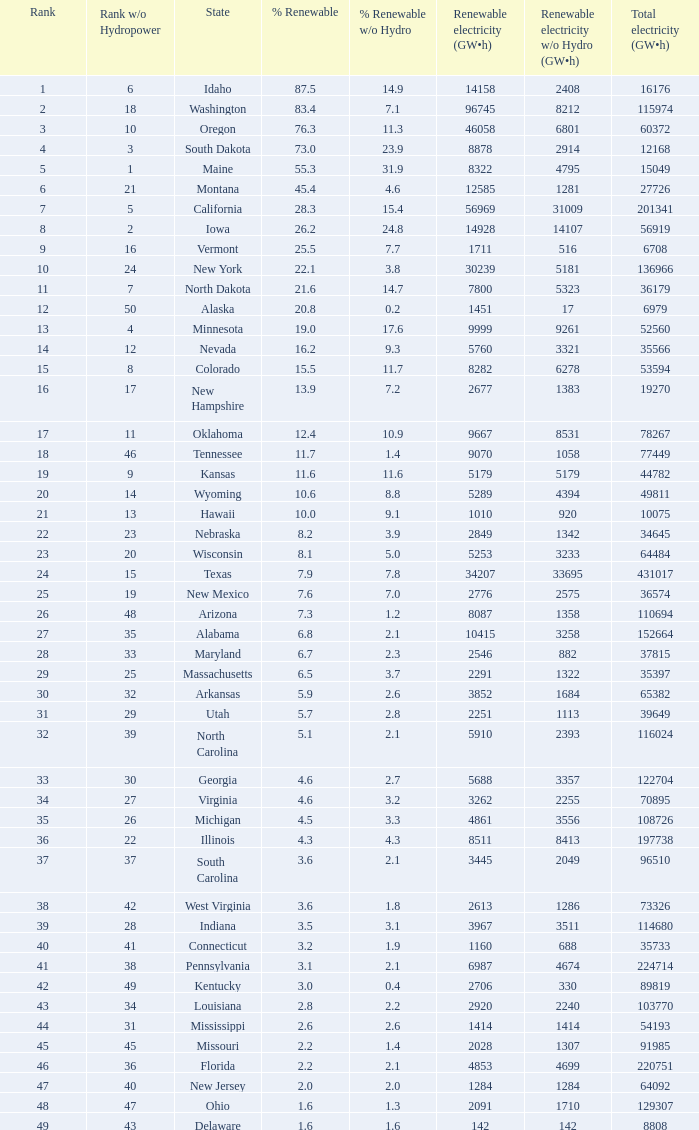Could you help me parse every detail presented in this table? {'header': ['Rank', 'Rank w/o Hydropower', 'State', '% Renewable', '% Renewable w/o Hydro', 'Renewable electricity (GW•h)', 'Renewable electricity w/o Hydro (GW•h)', 'Total electricity (GW•h)'], 'rows': [['1', '6', 'Idaho', '87.5', '14.9', '14158', '2408', '16176'], ['2', '18', 'Washington', '83.4', '7.1', '96745', '8212', '115974'], ['3', '10', 'Oregon', '76.3', '11.3', '46058', '6801', '60372'], ['4', '3', 'South Dakota', '73.0', '23.9', '8878', '2914', '12168'], ['5', '1', 'Maine', '55.3', '31.9', '8322', '4795', '15049'], ['6', '21', 'Montana', '45.4', '4.6', '12585', '1281', '27726'], ['7', '5', 'California', '28.3', '15.4', '56969', '31009', '201341'], ['8', '2', 'Iowa', '26.2', '24.8', '14928', '14107', '56919'], ['9', '16', 'Vermont', '25.5', '7.7', '1711', '516', '6708'], ['10', '24', 'New York', '22.1', '3.8', '30239', '5181', '136966'], ['11', '7', 'North Dakota', '21.6', '14.7', '7800', '5323', '36179'], ['12', '50', 'Alaska', '20.8', '0.2', '1451', '17', '6979'], ['13', '4', 'Minnesota', '19.0', '17.6', '9999', '9261', '52560'], ['14', '12', 'Nevada', '16.2', '9.3', '5760', '3321', '35566'], ['15', '8', 'Colorado', '15.5', '11.7', '8282', '6278', '53594'], ['16', '17', 'New Hampshire', '13.9', '7.2', '2677', '1383', '19270'], ['17', '11', 'Oklahoma', '12.4', '10.9', '9667', '8531', '78267'], ['18', '46', 'Tennessee', '11.7', '1.4', '9070', '1058', '77449'], ['19', '9', 'Kansas', '11.6', '11.6', '5179', '5179', '44782'], ['20', '14', 'Wyoming', '10.6', '8.8', '5289', '4394', '49811'], ['21', '13', 'Hawaii', '10.0', '9.1', '1010', '920', '10075'], ['22', '23', 'Nebraska', '8.2', '3.9', '2849', '1342', '34645'], ['23', '20', 'Wisconsin', '8.1', '5.0', '5253', '3233', '64484'], ['24', '15', 'Texas', '7.9', '7.8', '34207', '33695', '431017'], ['25', '19', 'New Mexico', '7.6', '7.0', '2776', '2575', '36574'], ['26', '48', 'Arizona', '7.3', '1.2', '8087', '1358', '110694'], ['27', '35', 'Alabama', '6.8', '2.1', '10415', '3258', '152664'], ['28', '33', 'Maryland', '6.7', '2.3', '2546', '882', '37815'], ['29', '25', 'Massachusetts', '6.5', '3.7', '2291', '1322', '35397'], ['30', '32', 'Arkansas', '5.9', '2.6', '3852', '1684', '65382'], ['31', '29', 'Utah', '5.7', '2.8', '2251', '1113', '39649'], ['32', '39', 'North Carolina', '5.1', '2.1', '5910', '2393', '116024'], ['33', '30', 'Georgia', '4.6', '2.7', '5688', '3357', '122704'], ['34', '27', 'Virginia', '4.6', '3.2', '3262', '2255', '70895'], ['35', '26', 'Michigan', '4.5', '3.3', '4861', '3556', '108726'], ['36', '22', 'Illinois', '4.3', '4.3', '8511', '8413', '197738'], ['37', '37', 'South Carolina', '3.6', '2.1', '3445', '2049', '96510'], ['38', '42', 'West Virginia', '3.6', '1.8', '2613', '1286', '73326'], ['39', '28', 'Indiana', '3.5', '3.1', '3967', '3511', '114680'], ['40', '41', 'Connecticut', '3.2', '1.9', '1160', '688', '35733'], ['41', '38', 'Pennsylvania', '3.1', '2.1', '6987', '4674', '224714'], ['42', '49', 'Kentucky', '3.0', '0.4', '2706', '330', '89819'], ['43', '34', 'Louisiana', '2.8', '2.2', '2920', '2240', '103770'], ['44', '31', 'Mississippi', '2.6', '2.6', '1414', '1414', '54193'], ['45', '45', 'Missouri', '2.2', '1.4', '2028', '1307', '91985'], ['46', '36', 'Florida', '2.2', '2.1', '4853', '4699', '220751'], ['47', '40', 'New Jersey', '2.0', '2.0', '1284', '1284', '64092'], ['48', '47', 'Ohio', '1.6', '1.3', '2091', '1710', '129307'], ['49', '43', 'Delaware', '1.6', '1.6', '142', '142', '8808']]} In south dakota, what proportion of the renewable electricity excludes hydrogen power? 23.9. 